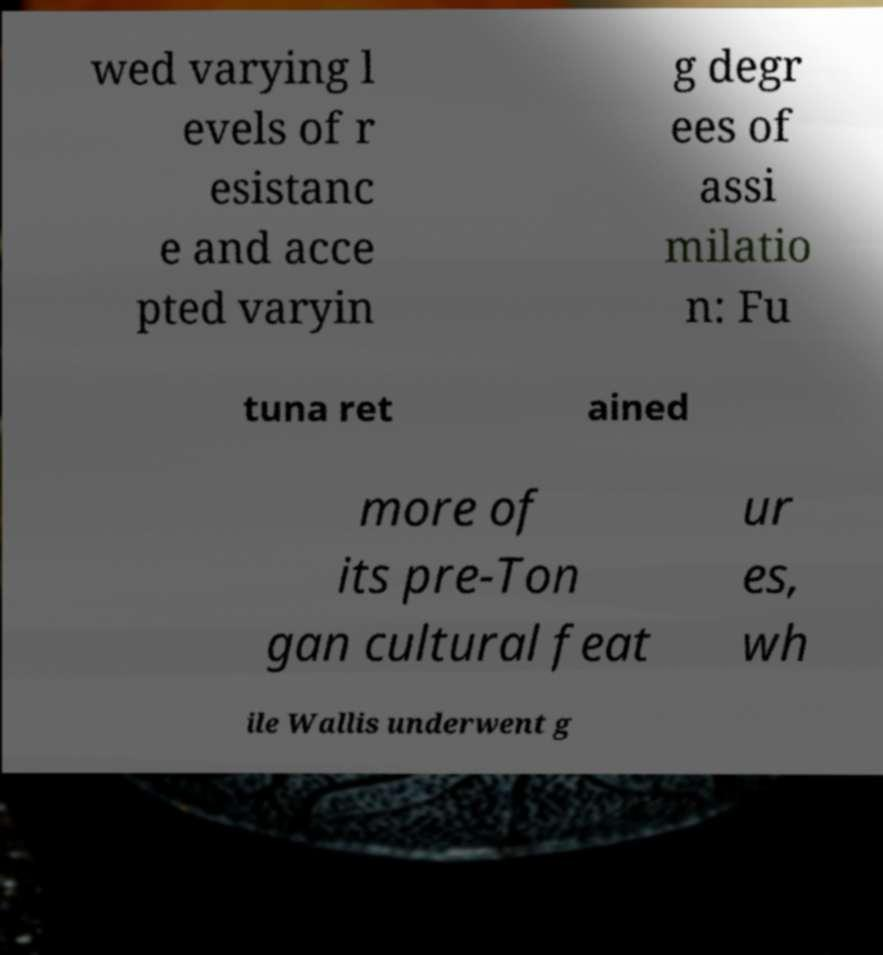Please identify and transcribe the text found in this image. wed varying l evels of r esistanc e and acce pted varyin g degr ees of assi milatio n: Fu tuna ret ained more of its pre-Ton gan cultural feat ur es, wh ile Wallis underwent g 